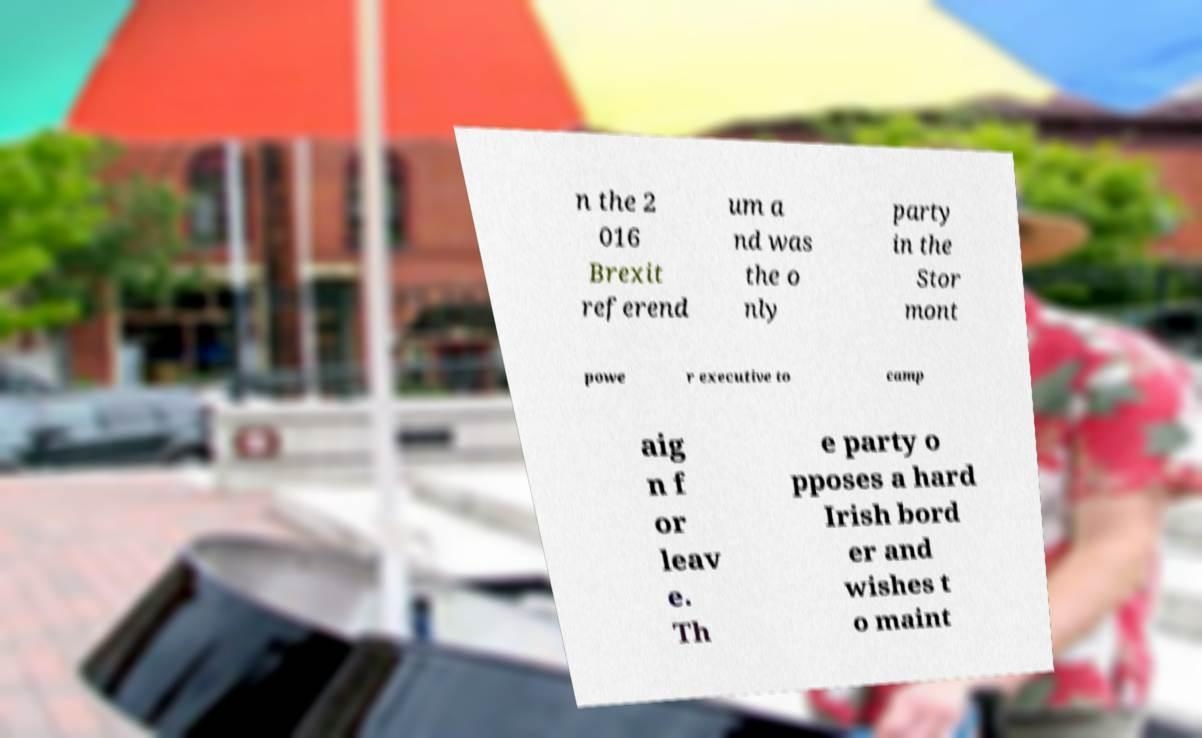Could you extract and type out the text from this image? n the 2 016 Brexit referend um a nd was the o nly party in the Stor mont powe r executive to camp aig n f or leav e. Th e party o pposes a hard Irish bord er and wishes t o maint 